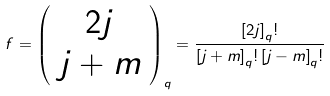<formula> <loc_0><loc_0><loc_500><loc_500>f = \left ( \begin{array} { c } 2 j \\ j + m \end{array} \right ) _ { q } = \frac { \left [ 2 j \right ] _ { q } ! } { \left [ j + m \right ] _ { q } ! \left [ j - m \right ] _ { q } ! }</formula> 